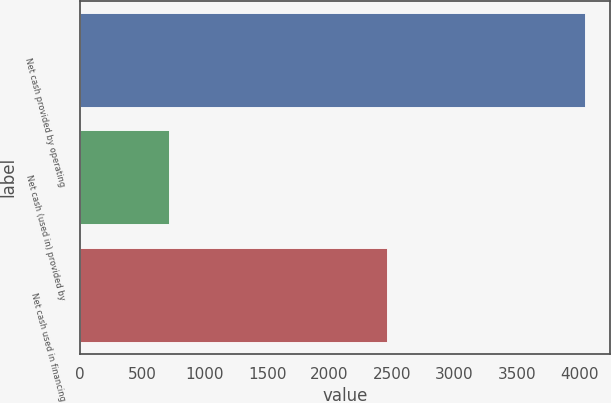<chart> <loc_0><loc_0><loc_500><loc_500><bar_chart><fcel>Net cash provided by operating<fcel>Net cash (used in) provided by<fcel>Net cash used in financing<nl><fcel>4043<fcel>715<fcel>2458<nl></chart> 